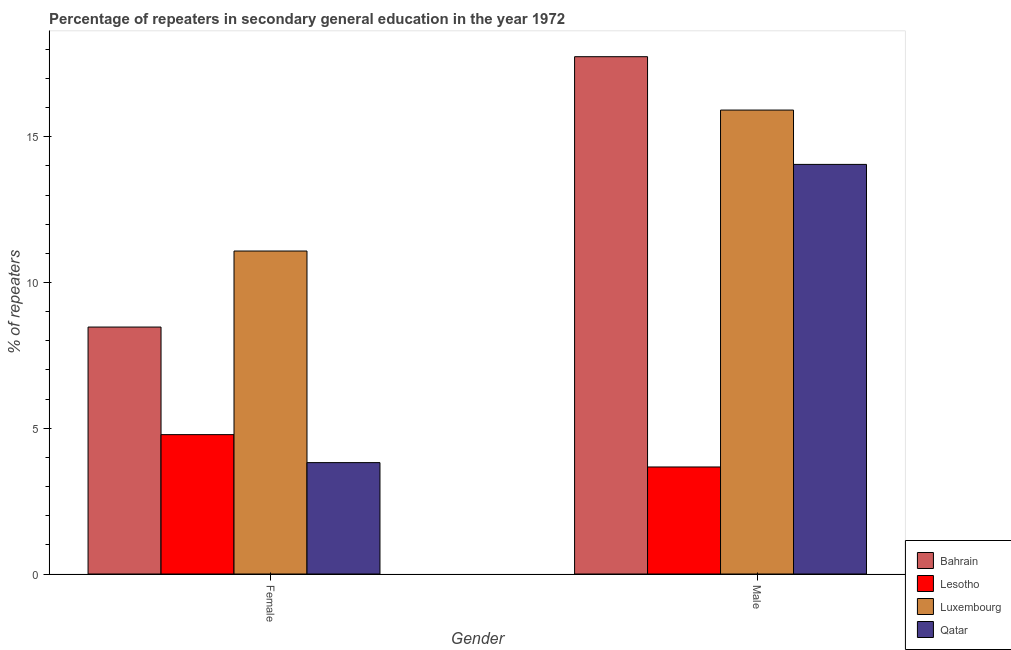How many different coloured bars are there?
Offer a very short reply. 4. How many groups of bars are there?
Provide a short and direct response. 2. Are the number of bars per tick equal to the number of legend labels?
Your response must be concise. Yes. How many bars are there on the 1st tick from the right?
Offer a terse response. 4. What is the percentage of male repeaters in Luxembourg?
Ensure brevity in your answer.  15.92. Across all countries, what is the maximum percentage of female repeaters?
Your answer should be very brief. 11.08. Across all countries, what is the minimum percentage of female repeaters?
Your response must be concise. 3.82. In which country was the percentage of male repeaters maximum?
Your answer should be compact. Bahrain. In which country was the percentage of male repeaters minimum?
Make the answer very short. Lesotho. What is the total percentage of female repeaters in the graph?
Provide a short and direct response. 28.15. What is the difference between the percentage of female repeaters in Qatar and that in Bahrain?
Offer a very short reply. -4.65. What is the difference between the percentage of male repeaters in Bahrain and the percentage of female repeaters in Luxembourg?
Offer a very short reply. 6.67. What is the average percentage of male repeaters per country?
Ensure brevity in your answer.  12.85. What is the difference between the percentage of male repeaters and percentage of female repeaters in Qatar?
Offer a very short reply. 10.23. In how many countries, is the percentage of female repeaters greater than 14 %?
Your response must be concise. 0. What is the ratio of the percentage of female repeaters in Luxembourg to that in Lesotho?
Your response must be concise. 2.32. Is the percentage of female repeaters in Luxembourg less than that in Lesotho?
Keep it short and to the point. No. What does the 4th bar from the left in Female represents?
Keep it short and to the point. Qatar. What does the 2nd bar from the right in Female represents?
Your answer should be compact. Luxembourg. How many bars are there?
Your answer should be compact. 8. Are the values on the major ticks of Y-axis written in scientific E-notation?
Offer a very short reply. No. Does the graph contain any zero values?
Provide a short and direct response. No. Does the graph contain grids?
Your response must be concise. No. How many legend labels are there?
Provide a succinct answer. 4. How are the legend labels stacked?
Your response must be concise. Vertical. What is the title of the graph?
Make the answer very short. Percentage of repeaters in secondary general education in the year 1972. Does "Montenegro" appear as one of the legend labels in the graph?
Your response must be concise. No. What is the label or title of the X-axis?
Your answer should be very brief. Gender. What is the label or title of the Y-axis?
Give a very brief answer. % of repeaters. What is the % of repeaters of Bahrain in Female?
Your response must be concise. 8.47. What is the % of repeaters of Lesotho in Female?
Offer a very short reply. 4.78. What is the % of repeaters of Luxembourg in Female?
Your response must be concise. 11.08. What is the % of repeaters of Qatar in Female?
Your answer should be very brief. 3.82. What is the % of repeaters in Bahrain in Male?
Ensure brevity in your answer.  17.75. What is the % of repeaters in Lesotho in Male?
Keep it short and to the point. 3.67. What is the % of repeaters of Luxembourg in Male?
Your answer should be compact. 15.92. What is the % of repeaters in Qatar in Male?
Your response must be concise. 14.05. Across all Gender, what is the maximum % of repeaters in Bahrain?
Keep it short and to the point. 17.75. Across all Gender, what is the maximum % of repeaters of Lesotho?
Offer a very short reply. 4.78. Across all Gender, what is the maximum % of repeaters in Luxembourg?
Provide a succinct answer. 15.92. Across all Gender, what is the maximum % of repeaters of Qatar?
Your answer should be very brief. 14.05. Across all Gender, what is the minimum % of repeaters in Bahrain?
Ensure brevity in your answer.  8.47. Across all Gender, what is the minimum % of repeaters in Lesotho?
Provide a short and direct response. 3.67. Across all Gender, what is the minimum % of repeaters in Luxembourg?
Your answer should be compact. 11.08. Across all Gender, what is the minimum % of repeaters of Qatar?
Provide a short and direct response. 3.82. What is the total % of repeaters of Bahrain in the graph?
Keep it short and to the point. 26.22. What is the total % of repeaters in Lesotho in the graph?
Your response must be concise. 8.45. What is the total % of repeaters in Luxembourg in the graph?
Ensure brevity in your answer.  27. What is the total % of repeaters of Qatar in the graph?
Your response must be concise. 17.87. What is the difference between the % of repeaters of Bahrain in Female and that in Male?
Provide a short and direct response. -9.28. What is the difference between the % of repeaters of Lesotho in Female and that in Male?
Ensure brevity in your answer.  1.11. What is the difference between the % of repeaters in Luxembourg in Female and that in Male?
Make the answer very short. -4.84. What is the difference between the % of repeaters in Qatar in Female and that in Male?
Your answer should be very brief. -10.23. What is the difference between the % of repeaters of Bahrain in Female and the % of repeaters of Lesotho in Male?
Offer a terse response. 4.8. What is the difference between the % of repeaters of Bahrain in Female and the % of repeaters of Luxembourg in Male?
Offer a terse response. -7.44. What is the difference between the % of repeaters of Bahrain in Female and the % of repeaters of Qatar in Male?
Make the answer very short. -5.58. What is the difference between the % of repeaters in Lesotho in Female and the % of repeaters in Luxembourg in Male?
Keep it short and to the point. -11.13. What is the difference between the % of repeaters of Lesotho in Female and the % of repeaters of Qatar in Male?
Ensure brevity in your answer.  -9.27. What is the difference between the % of repeaters of Luxembourg in Female and the % of repeaters of Qatar in Male?
Ensure brevity in your answer.  -2.97. What is the average % of repeaters in Bahrain per Gender?
Ensure brevity in your answer.  13.11. What is the average % of repeaters in Lesotho per Gender?
Offer a terse response. 4.23. What is the average % of repeaters in Luxembourg per Gender?
Provide a succinct answer. 13.5. What is the average % of repeaters of Qatar per Gender?
Offer a very short reply. 8.94. What is the difference between the % of repeaters in Bahrain and % of repeaters in Lesotho in Female?
Your response must be concise. 3.69. What is the difference between the % of repeaters of Bahrain and % of repeaters of Luxembourg in Female?
Offer a terse response. -2.61. What is the difference between the % of repeaters of Bahrain and % of repeaters of Qatar in Female?
Your answer should be very brief. 4.65. What is the difference between the % of repeaters of Lesotho and % of repeaters of Luxembourg in Female?
Offer a terse response. -6.3. What is the difference between the % of repeaters of Lesotho and % of repeaters of Qatar in Female?
Your answer should be compact. 0.96. What is the difference between the % of repeaters in Luxembourg and % of repeaters in Qatar in Female?
Make the answer very short. 7.26. What is the difference between the % of repeaters of Bahrain and % of repeaters of Lesotho in Male?
Give a very brief answer. 14.08. What is the difference between the % of repeaters of Bahrain and % of repeaters of Luxembourg in Male?
Your answer should be compact. 1.83. What is the difference between the % of repeaters of Bahrain and % of repeaters of Qatar in Male?
Give a very brief answer. 3.7. What is the difference between the % of repeaters in Lesotho and % of repeaters in Luxembourg in Male?
Offer a terse response. -12.24. What is the difference between the % of repeaters in Lesotho and % of repeaters in Qatar in Male?
Provide a succinct answer. -10.38. What is the difference between the % of repeaters in Luxembourg and % of repeaters in Qatar in Male?
Make the answer very short. 1.86. What is the ratio of the % of repeaters of Bahrain in Female to that in Male?
Keep it short and to the point. 0.48. What is the ratio of the % of repeaters of Lesotho in Female to that in Male?
Provide a succinct answer. 1.3. What is the ratio of the % of repeaters in Luxembourg in Female to that in Male?
Keep it short and to the point. 0.7. What is the ratio of the % of repeaters of Qatar in Female to that in Male?
Offer a very short reply. 0.27. What is the difference between the highest and the second highest % of repeaters of Bahrain?
Keep it short and to the point. 9.28. What is the difference between the highest and the second highest % of repeaters of Lesotho?
Make the answer very short. 1.11. What is the difference between the highest and the second highest % of repeaters in Luxembourg?
Provide a succinct answer. 4.84. What is the difference between the highest and the second highest % of repeaters in Qatar?
Offer a very short reply. 10.23. What is the difference between the highest and the lowest % of repeaters in Bahrain?
Make the answer very short. 9.28. What is the difference between the highest and the lowest % of repeaters of Lesotho?
Give a very brief answer. 1.11. What is the difference between the highest and the lowest % of repeaters in Luxembourg?
Your response must be concise. 4.84. What is the difference between the highest and the lowest % of repeaters of Qatar?
Keep it short and to the point. 10.23. 